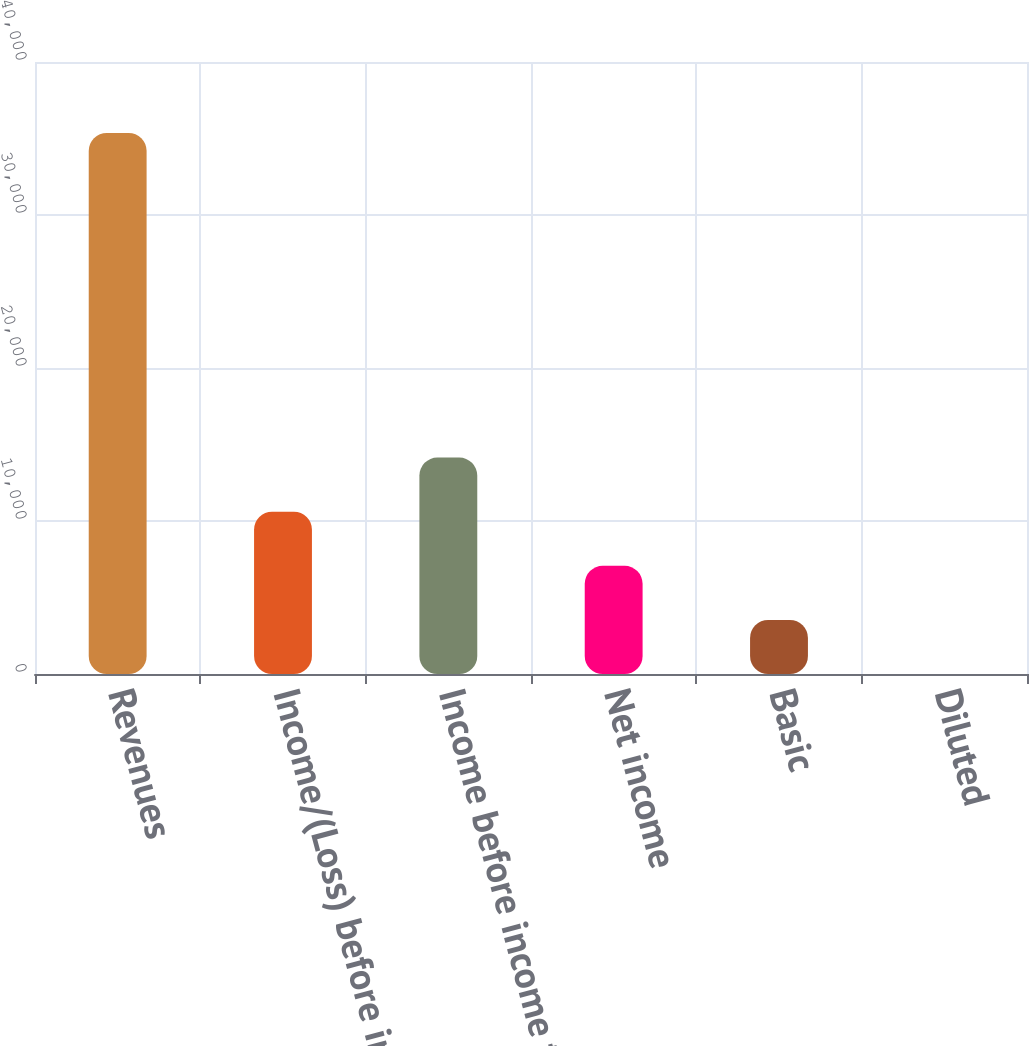<chart> <loc_0><loc_0><loc_500><loc_500><bar_chart><fcel>Revenues<fcel>Income/(Loss) before income<fcel>Income before income taxes<fcel>Net income<fcel>Basic<fcel>Diluted<nl><fcel>35365<fcel>10609.7<fcel>14146.2<fcel>7073.26<fcel>3536.79<fcel>0.32<nl></chart> 